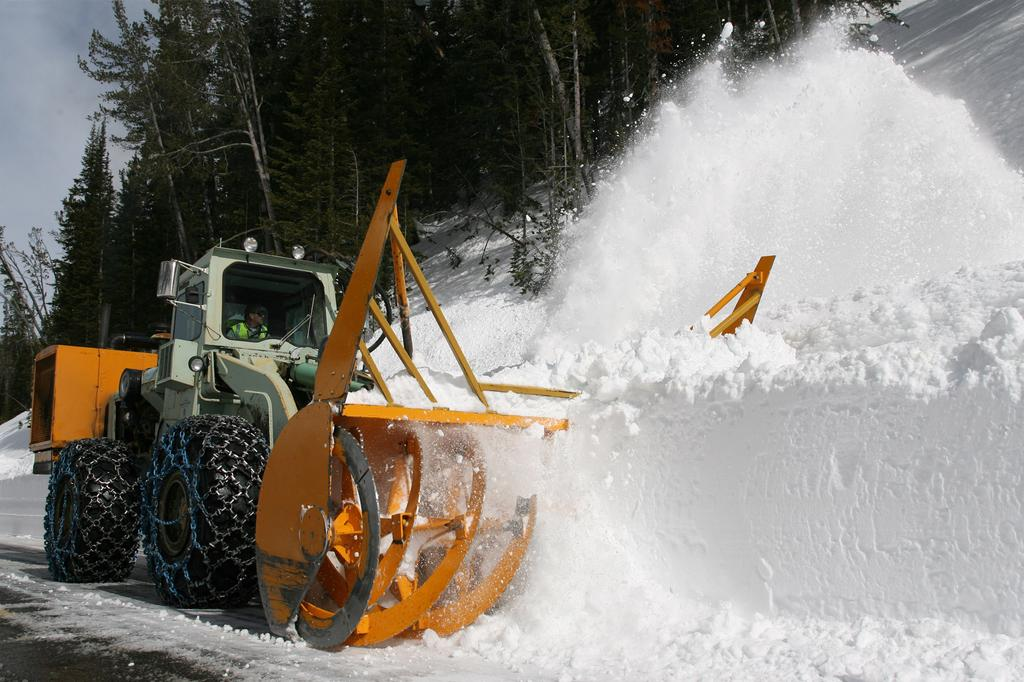What is the person in the image operating? The person in the image is operating a crushing vehicle. What type of weather is depicted in the image? There is snow in the image. What natural elements can be seen in the image? There are trees in the image. What is visible in the background of the image? The sky is visible in the background of the image. What type of doctor is present in the image? There is no doctor present in the image. What is the best way to reach the location depicted in the image? The image does not provide information about the location or the best way to reach it. 